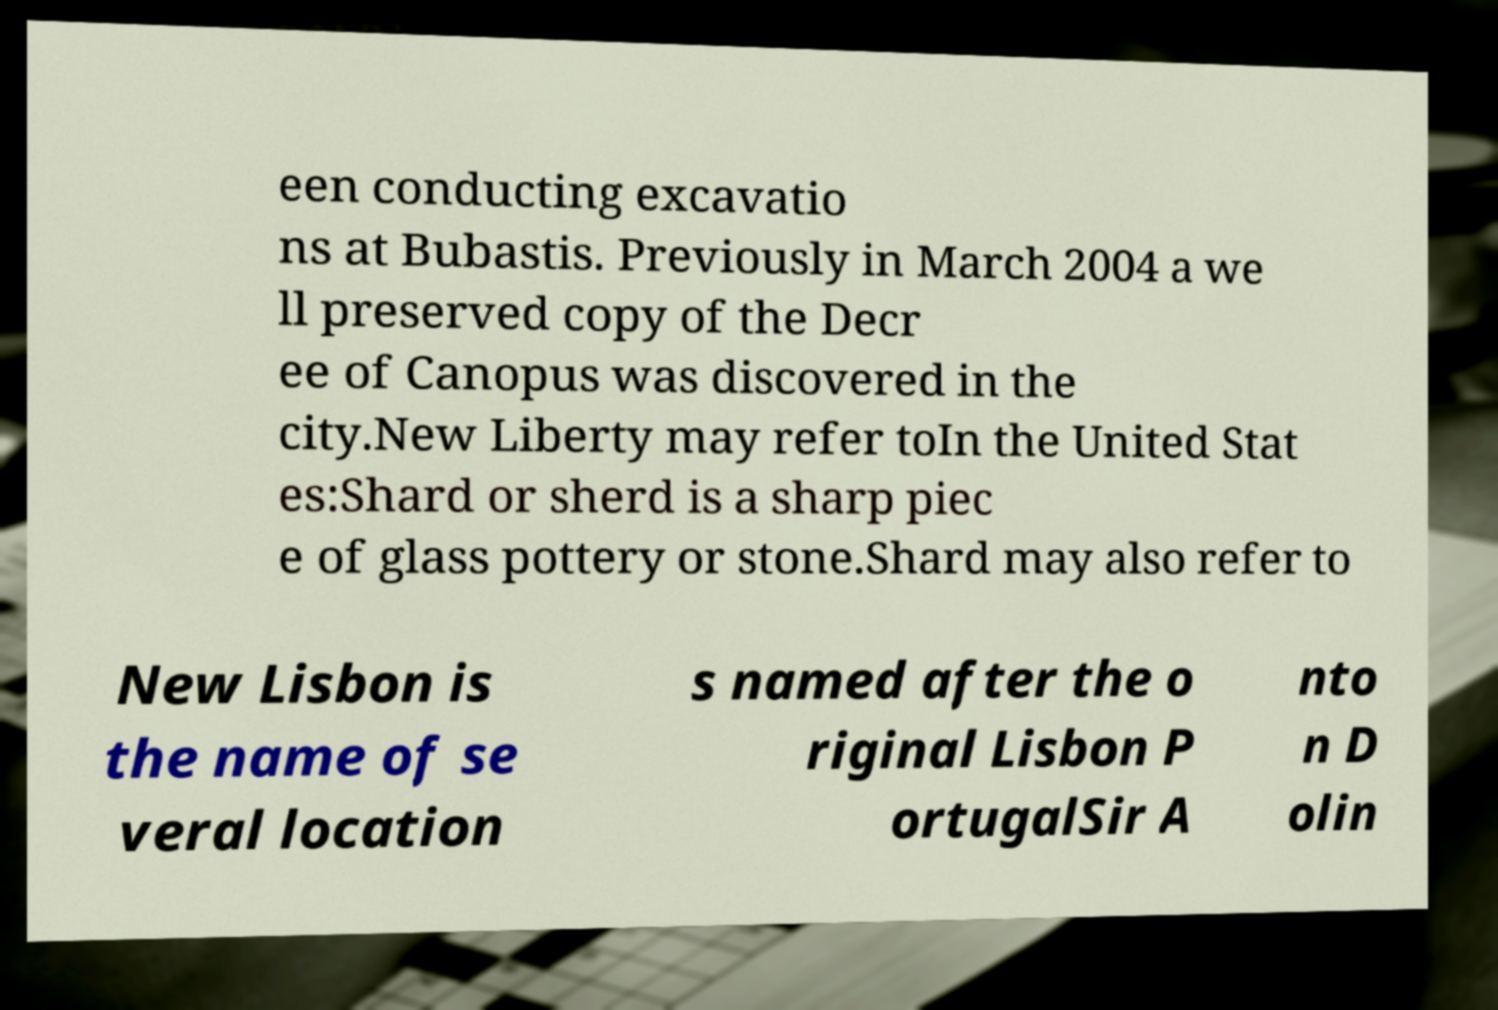I need the written content from this picture converted into text. Can you do that? een conducting excavatio ns at Bubastis. Previously in March 2004 a we ll preserved copy of the Decr ee of Canopus was discovered in the city.New Liberty may refer toIn the United Stat es:Shard or sherd is a sharp piec e of glass pottery or stone.Shard may also refer to New Lisbon is the name of se veral location s named after the o riginal Lisbon P ortugalSir A nto n D olin 